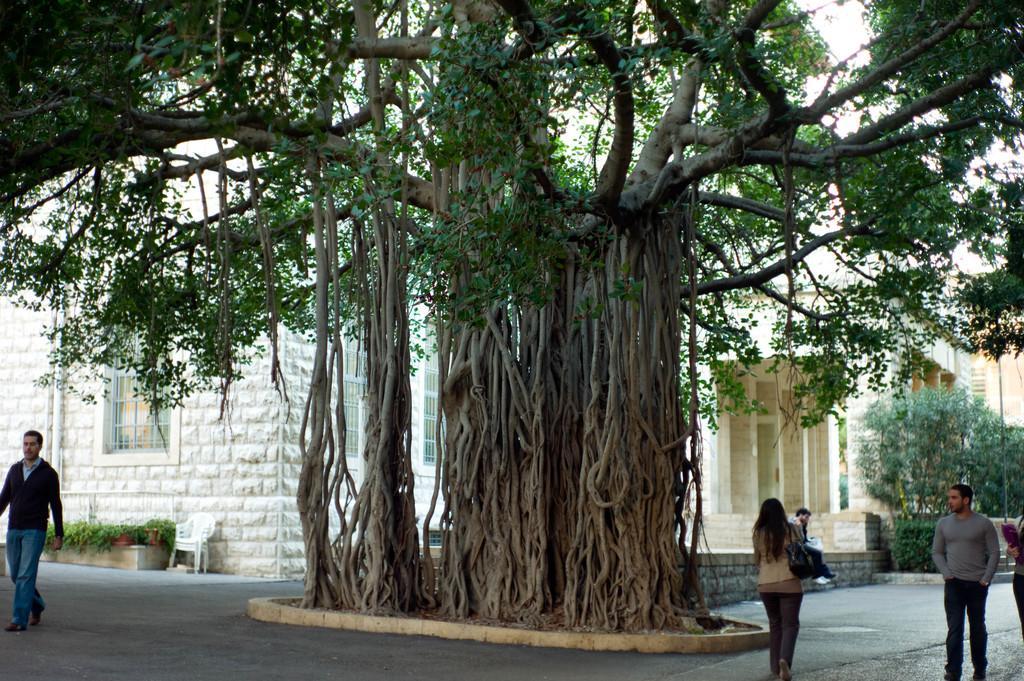In one or two sentences, can you explain what this image depicts? In this image I can see a group of people are walking on the road, trees, fence, buildings, houseplants, chairs and the sky. This image is taken may be during a day. 